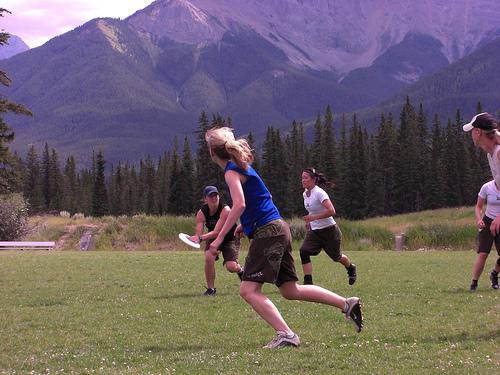Question: what is green?
Choices:
A. Leaves.
B. Grass.
C. Money.
D. Cars.
Answer with the letter. Answer: B Question: who is wearing a blue shirt?
Choices:
A. Woman with blonde hair.
B. Man with black hair.
C. Little boy.
D. A nurse.
Answer with the letter. Answer: A Question: where are little white flowers?
Choices:
A. In the grass.
B. By the barn.
C. Under the fence.
D. In the vase.
Answer with the letter. Answer: A Question: what is in the background?
Choices:
A. Trees.
B. Horses.
C. Mountains.
D. Pond.
Answer with the letter. Answer: C Question: where was the picture taken?
Choices:
A. By the barn.
B. On a mountain.
C. In a grassy field.
D. In a tree.
Answer with the letter. Answer: C Question: who is holding a frisbee?
Choices:
A. Woman in red.
B. Girl in pink.
C. Boy in green.
D. Person is blue hat.
Answer with the letter. Answer: D 